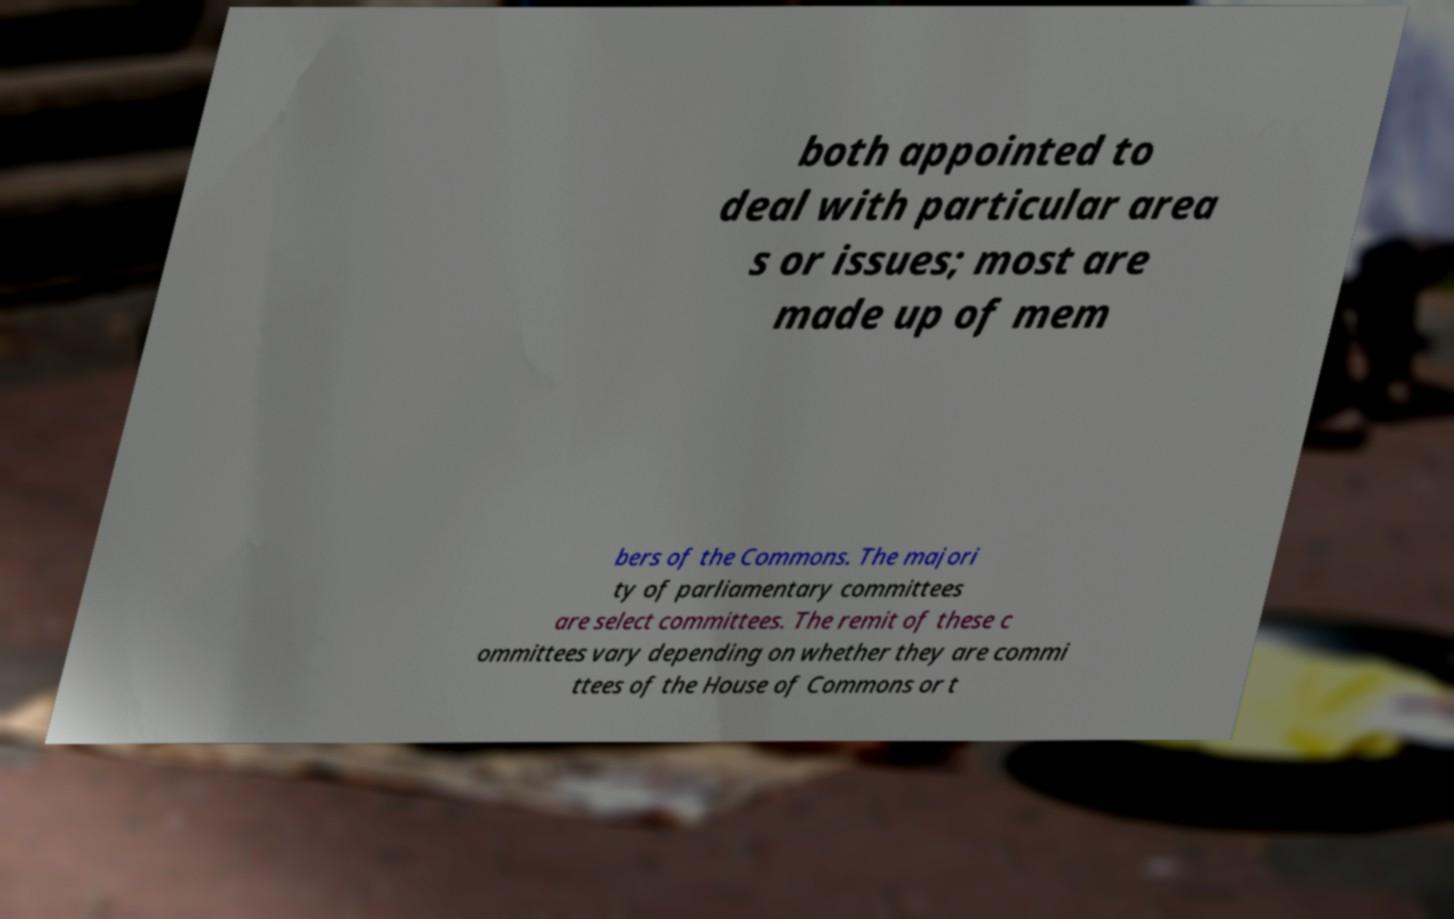Could you extract and type out the text from this image? both appointed to deal with particular area s or issues; most are made up of mem bers of the Commons. The majori ty of parliamentary committees are select committees. The remit of these c ommittees vary depending on whether they are commi ttees of the House of Commons or t 